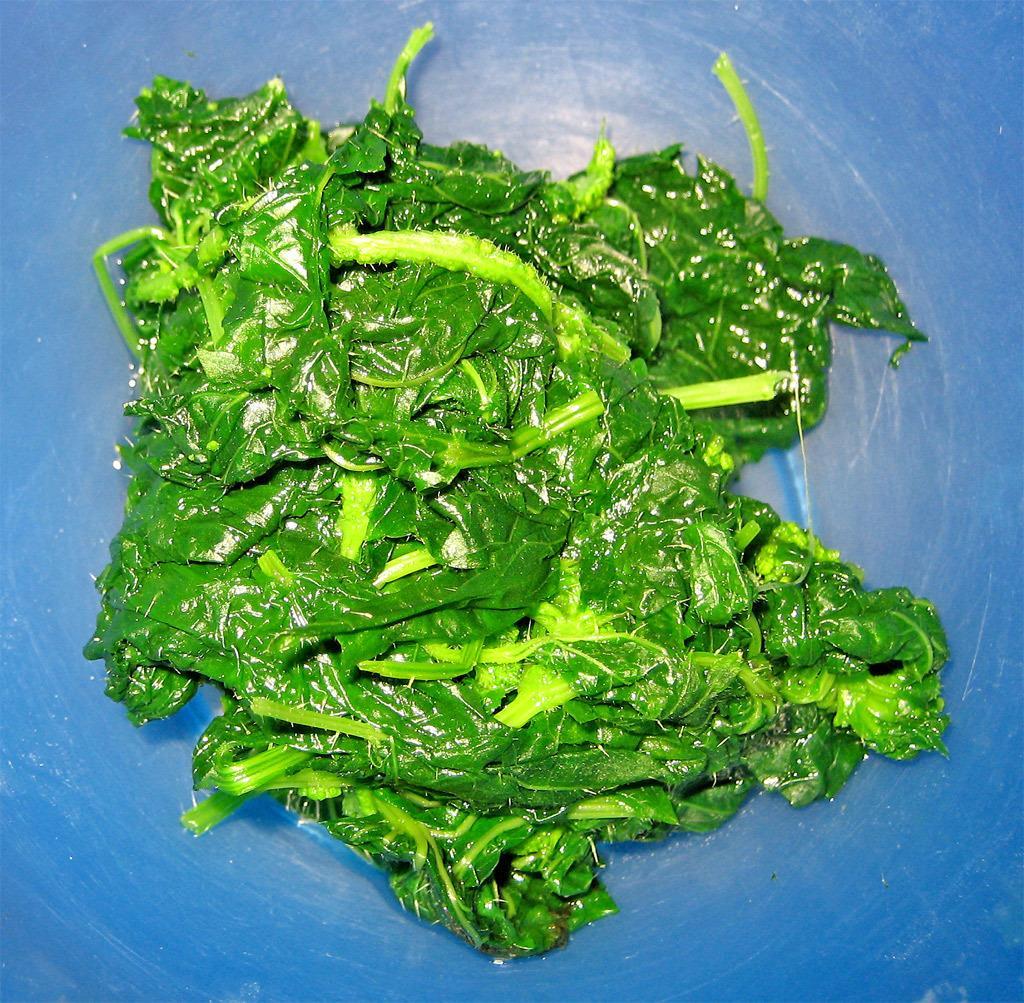How would you summarize this image in a sentence or two? This picture contains a green leafy vegetable and in the background, it is blue in color. 